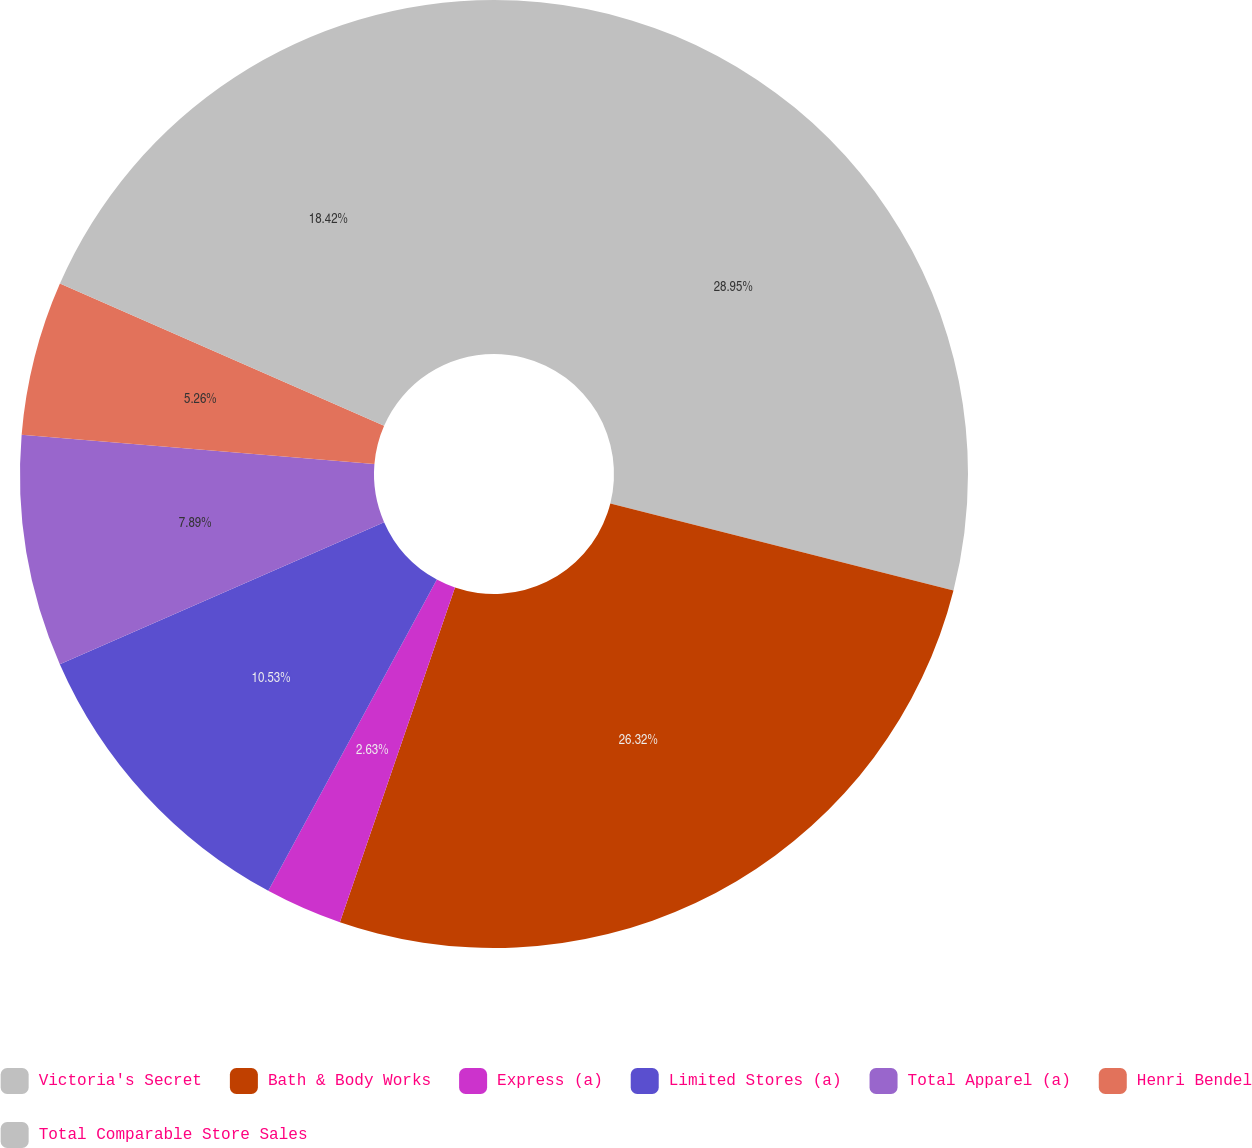Convert chart. <chart><loc_0><loc_0><loc_500><loc_500><pie_chart><fcel>Victoria's Secret<fcel>Bath & Body Works<fcel>Express (a)<fcel>Limited Stores (a)<fcel>Total Apparel (a)<fcel>Henri Bendel<fcel>Total Comparable Store Sales<nl><fcel>28.95%<fcel>26.32%<fcel>2.63%<fcel>10.53%<fcel>7.89%<fcel>5.26%<fcel>18.42%<nl></chart> 